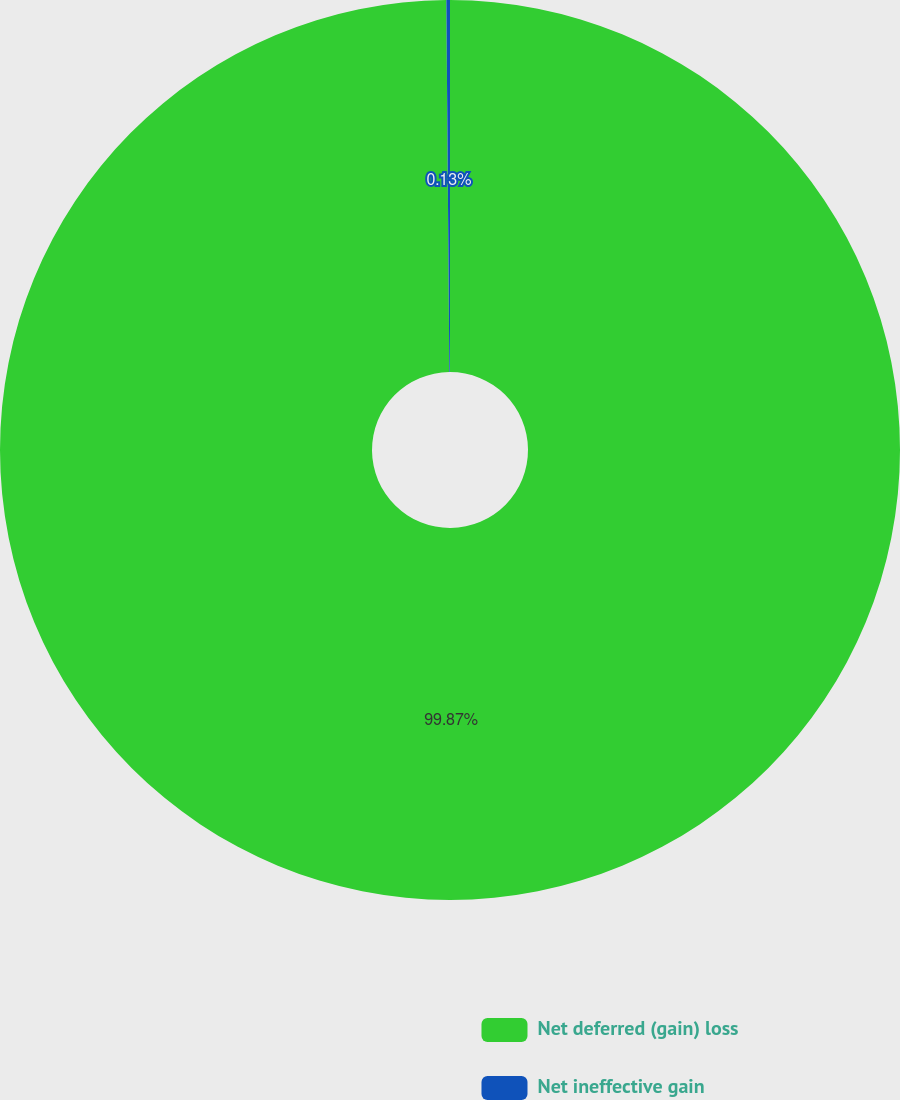<chart> <loc_0><loc_0><loc_500><loc_500><pie_chart><fcel>Net deferred (gain) loss<fcel>Net ineffective gain<nl><fcel>99.87%<fcel>0.13%<nl></chart> 